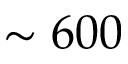Convert formula to latex. <formula><loc_0><loc_0><loc_500><loc_500>\sim 6 0 0</formula> 